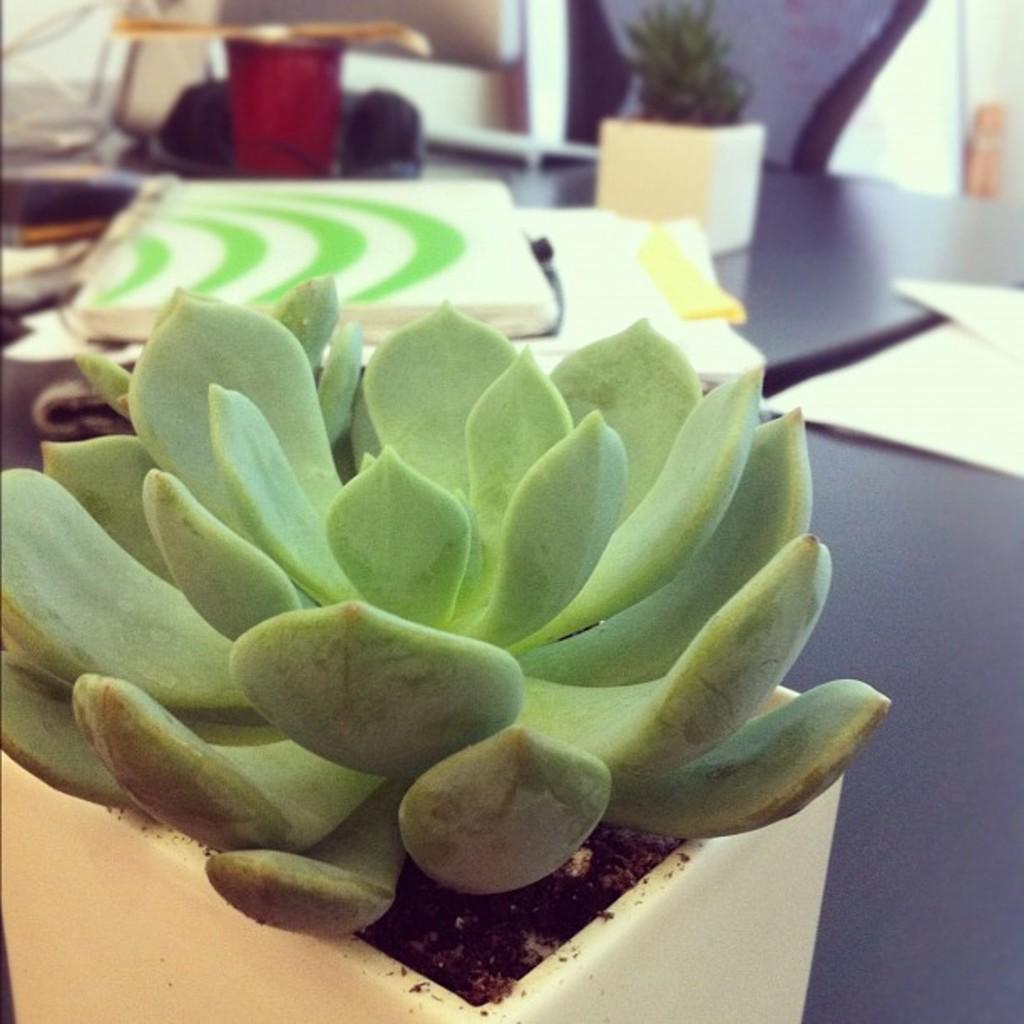How would you summarize this image in a sentence or two? In the picture I can see a plant in the flower pot which is kept on the black color table. The background of the image is slightly blurred, where we can see some objects and a flower pot is placed on it. Also, we can see the chair. 